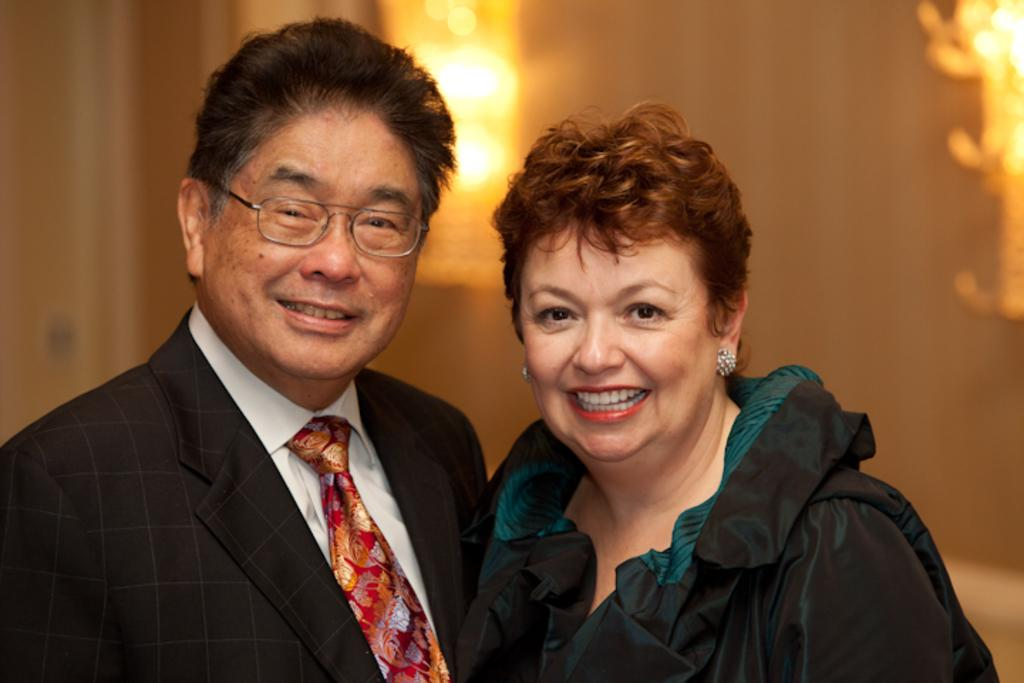Who is present in the image? There is a man and a woman in the image. What are the facial expressions of the people in the image? The man and the woman are both smiling. What type of waves can be seen in the image? There are no waves present in the image. What part of the woman's body is locked in the image? There is no lock or any indication of a locked body part in the image. 